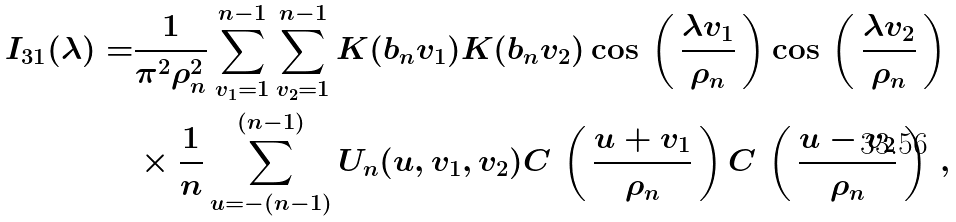<formula> <loc_0><loc_0><loc_500><loc_500>I _ { 3 1 } ( \lambda ) = & \frac { 1 } { \pi ^ { 2 } \rho _ { n } ^ { 2 } } \sum _ { v _ { 1 } = 1 } ^ { n - 1 } \sum _ { v _ { 2 } = 1 } ^ { n - 1 } K ( b _ { n } v _ { 1 } ) K ( b _ { n } v _ { 2 } ) \cos \, \left ( \, \frac { \lambda v _ { 1 } } { \rho _ { n } } \, \right ) \cos \, \left ( \, \frac { \lambda v _ { 2 } } { \rho _ { n } } \, \right ) \\ & \times \frac { 1 } { n } \sum _ { u = - ( n - 1 ) } ^ { ( n - 1 ) } U _ { n } ( u , v _ { 1 } , v _ { 2 } ) C \, \left ( \, \frac { u + v _ { 1 } } { \rho _ { n } } \, \right ) C \, \left ( \, \frac { u - v _ { 2 } } { \rho _ { n } } \, \right ) \, ,</formula> 